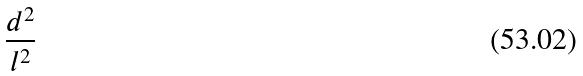Convert formula to latex. <formula><loc_0><loc_0><loc_500><loc_500>\frac { d ^ { 2 } } { l ^ { 2 } }</formula> 